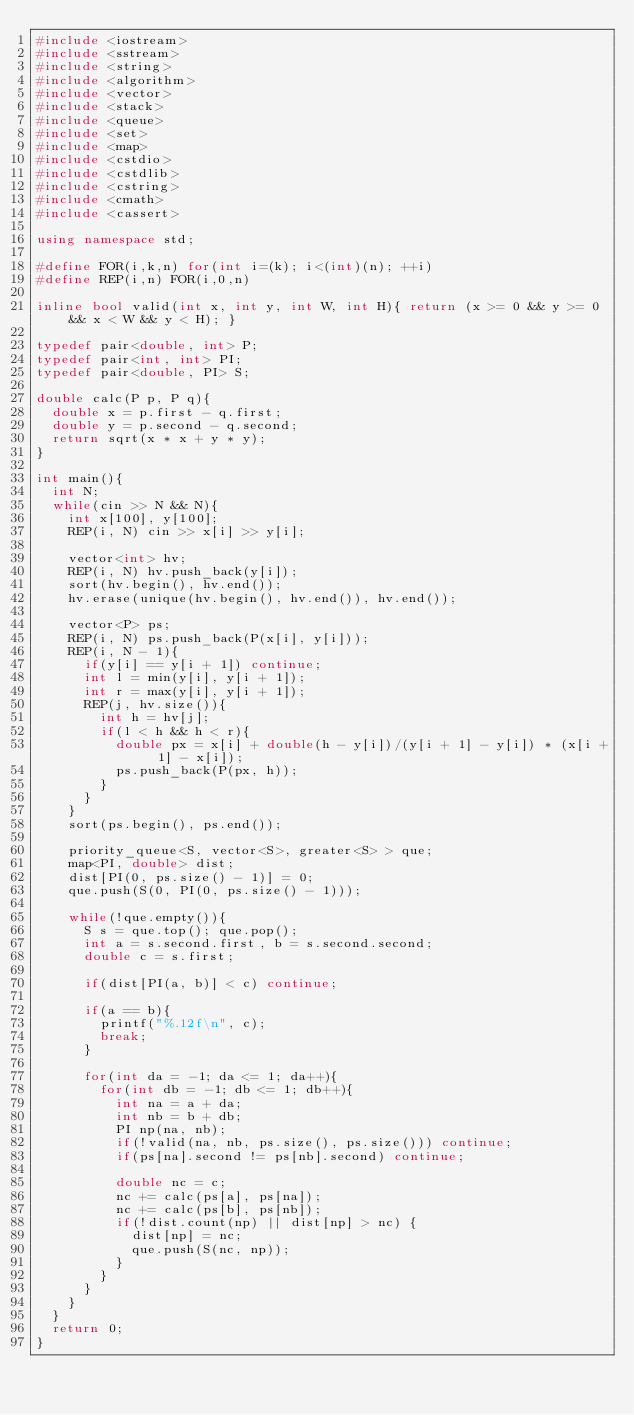Convert code to text. <code><loc_0><loc_0><loc_500><loc_500><_C++_>#include <iostream>
#include <sstream>
#include <string>
#include <algorithm>
#include <vector>
#include <stack>
#include <queue>
#include <set>
#include <map>
#include <cstdio>
#include <cstdlib>
#include <cstring>
#include <cmath>
#include <cassert>

using namespace std;

#define FOR(i,k,n) for(int i=(k); i<(int)(n); ++i)
#define REP(i,n) FOR(i,0,n)

inline bool valid(int x, int y, int W, int H){ return (x >= 0 && y >= 0 && x < W && y < H); }

typedef pair<double, int> P;
typedef pair<int, int> PI;
typedef pair<double, PI> S;

double calc(P p, P q){
  double x = p.first - q.first;
  double y = p.second - q.second;
  return sqrt(x * x + y * y);
}

int main(){
  int N;
  while(cin >> N && N){
    int x[100], y[100];
    REP(i, N) cin >> x[i] >> y[i];

    vector<int> hv;
    REP(i, N) hv.push_back(y[i]);
    sort(hv.begin(), hv.end());
    hv.erase(unique(hv.begin(), hv.end()), hv.end());

    vector<P> ps;
    REP(i, N) ps.push_back(P(x[i], y[i]));
    REP(i, N - 1){
      if(y[i] == y[i + 1]) continue;
      int l = min(y[i], y[i + 1]);
      int r = max(y[i], y[i + 1]);
      REP(j, hv.size()){
        int h = hv[j];
        if(l < h && h < r){
          double px = x[i] + double(h - y[i])/(y[i + 1] - y[i]) * (x[i + 1] - x[i]);
          ps.push_back(P(px, h));
        }
      }
    }
    sort(ps.begin(), ps.end());

    priority_queue<S, vector<S>, greater<S> > que;
    map<PI, double> dist;
    dist[PI(0, ps.size() - 1)] = 0;
    que.push(S(0, PI(0, ps.size() - 1)));

    while(!que.empty()){
      S s = que.top(); que.pop();
      int a = s.second.first, b = s.second.second;
      double c = s.first;

      if(dist[PI(a, b)] < c) continue;

      if(a == b){
        printf("%.12f\n", c);
        break;
      }

      for(int da = -1; da <= 1; da++){
        for(int db = -1; db <= 1; db++){
          int na = a + da;
          int nb = b + db;
          PI np(na, nb);
          if(!valid(na, nb, ps.size(), ps.size())) continue;
          if(ps[na].second != ps[nb].second) continue;

          double nc = c;
          nc += calc(ps[a], ps[na]);
          nc += calc(ps[b], ps[nb]);
          if(!dist.count(np) || dist[np] > nc) {
            dist[np] = nc;
            que.push(S(nc, np));
          }
        }
      }
    }
  }
  return 0;
}</code> 